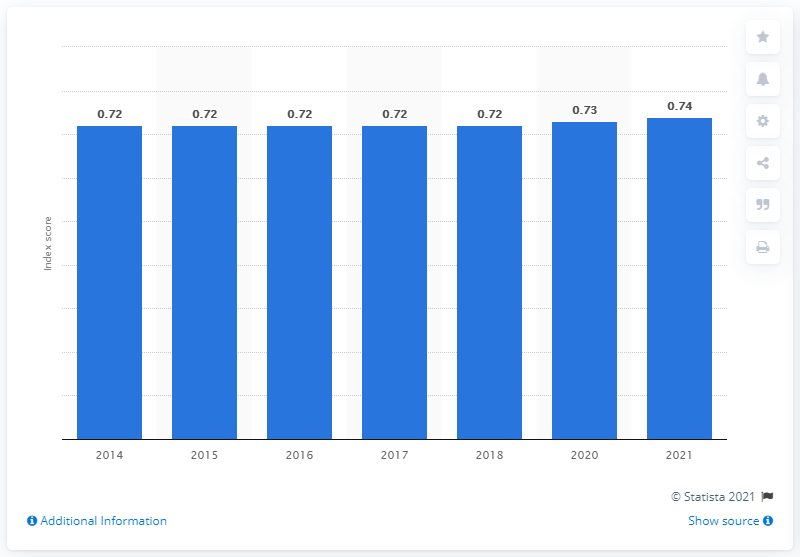List a handful of essential elements in this visual. In the year 2021, Panama scored 0.737 on the gender gap index. 